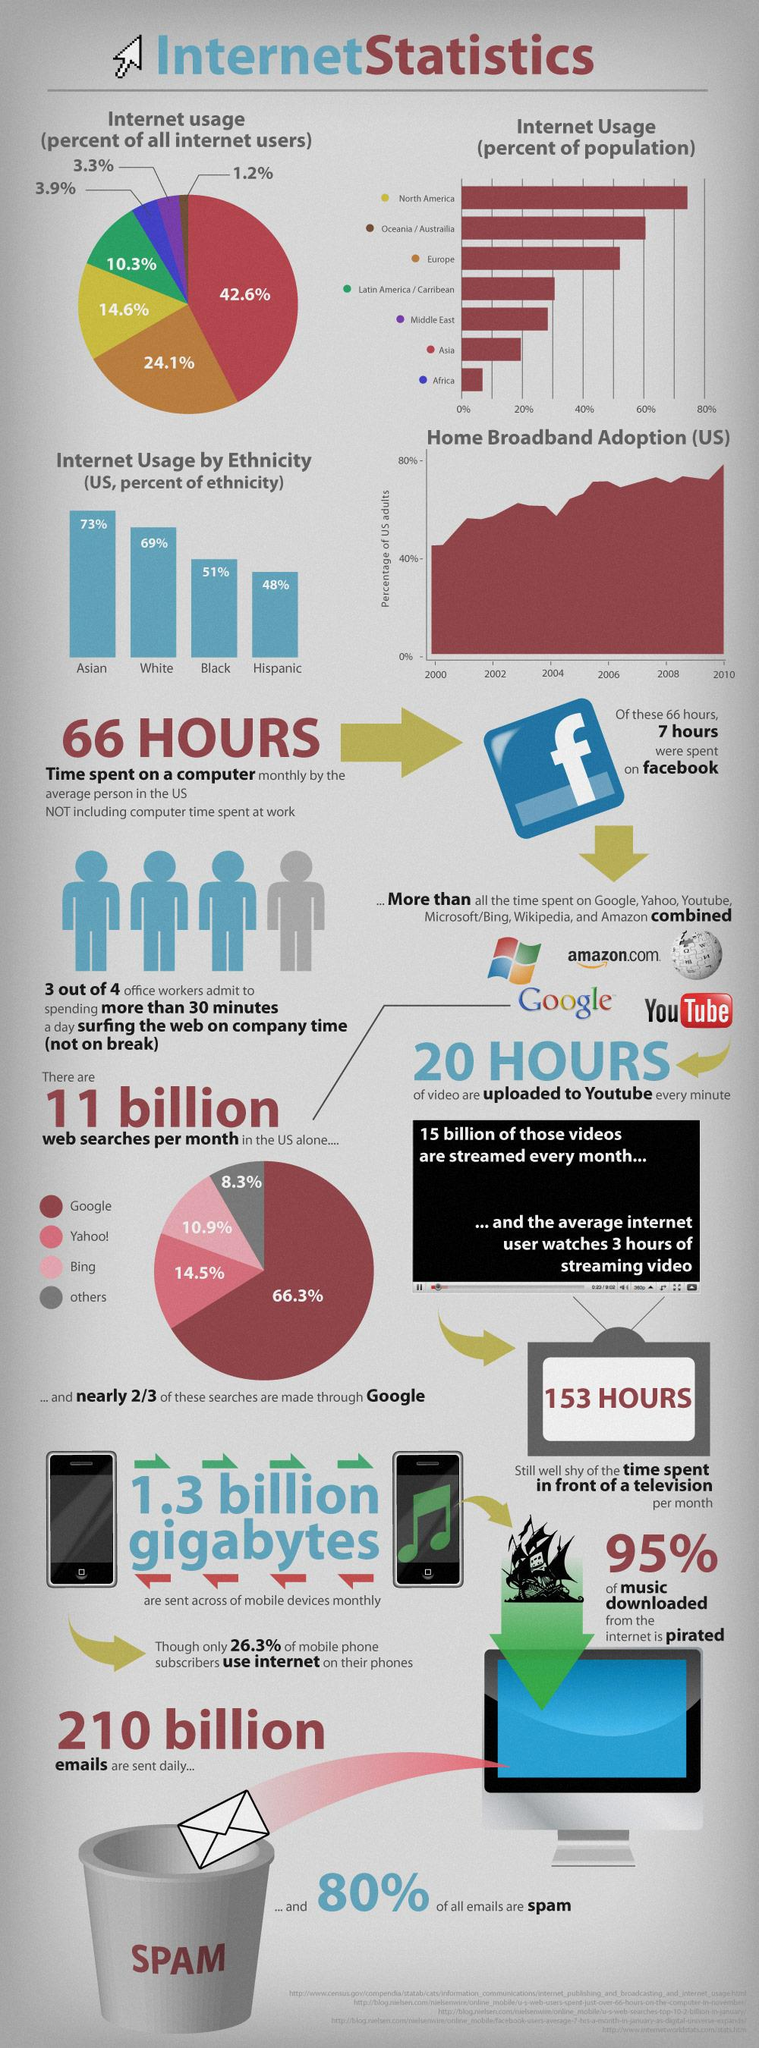Specify some key components in this picture. Nine out of 10 music downloads from the internet are pirated. According to internet statistics in the U.S., approximately 20% of all emails sent are not spam. According to recent estimates, over 210 billion emails are sent daily around the world. Approximately 66.3% of Google searches per month were done in the United States. The average person in the US spends approximately 66 hours per month on a computer, excluding the time spent at work. 